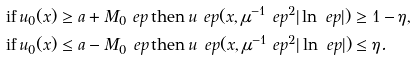<formula> <loc_0><loc_0><loc_500><loc_500>& \text {if} \, u _ { 0 } ( x ) \geq a + M _ { 0 } \ e p \, \text {then} \, u ^ { \ } e p ( x , \mu ^ { - 1 } \ e p ^ { 2 } | \ln \ e p | ) \geq 1 - \eta , \\ & \text {if} \, u _ { 0 } ( x ) \leq a - M _ { 0 } \ e p \, \text {then} \, u ^ { \ } e p ( x , \mu ^ { - 1 } \ e p ^ { 2 } | \ln \ e p | ) \leq \eta .</formula> 